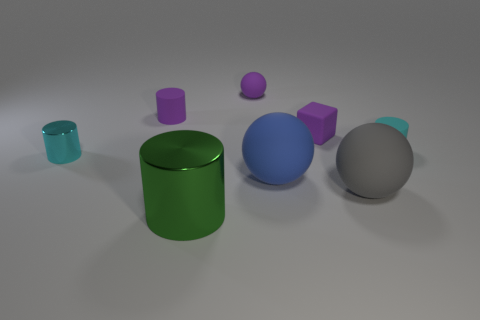How many cyan cylinders must be subtracted to get 1 cyan cylinders? 1 Add 1 purple rubber cylinders. How many objects exist? 9 Subtract all tiny cylinders. How many cylinders are left? 1 Subtract all purple cylinders. How many cylinders are left? 3 Subtract 2 spheres. How many spheres are left? 1 Subtract all gray spheres. How many red cylinders are left? 0 Subtract all gray matte things. Subtract all big green shiny cylinders. How many objects are left? 6 Add 3 tiny cyan metallic cylinders. How many tiny cyan metallic cylinders are left? 4 Add 4 big gray matte balls. How many big gray matte balls exist? 5 Subtract 0 yellow cylinders. How many objects are left? 8 